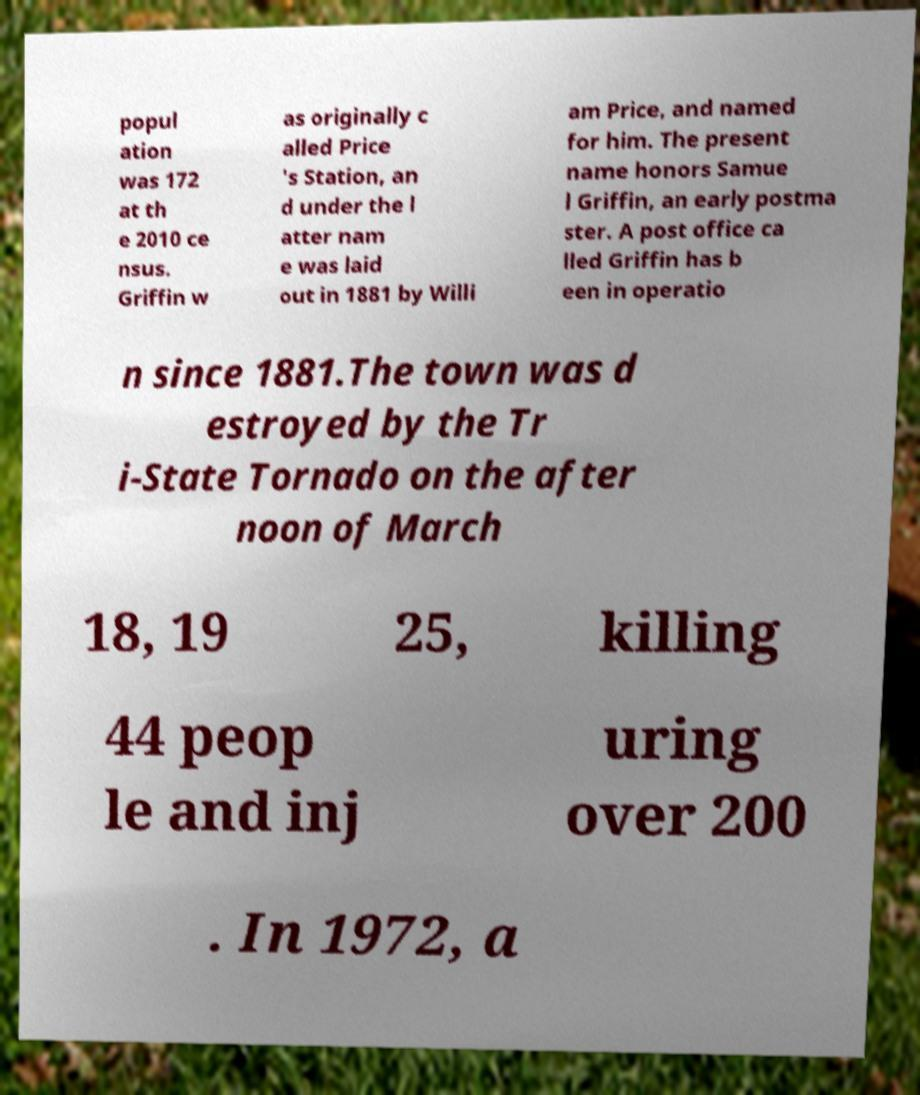Can you accurately transcribe the text from the provided image for me? popul ation was 172 at th e 2010 ce nsus. Griffin w as originally c alled Price 's Station, an d under the l atter nam e was laid out in 1881 by Willi am Price, and named for him. The present name honors Samue l Griffin, an early postma ster. A post office ca lled Griffin has b een in operatio n since 1881.The town was d estroyed by the Tr i-State Tornado on the after noon of March 18, 19 25, killing 44 peop le and inj uring over 200 . In 1972, a 